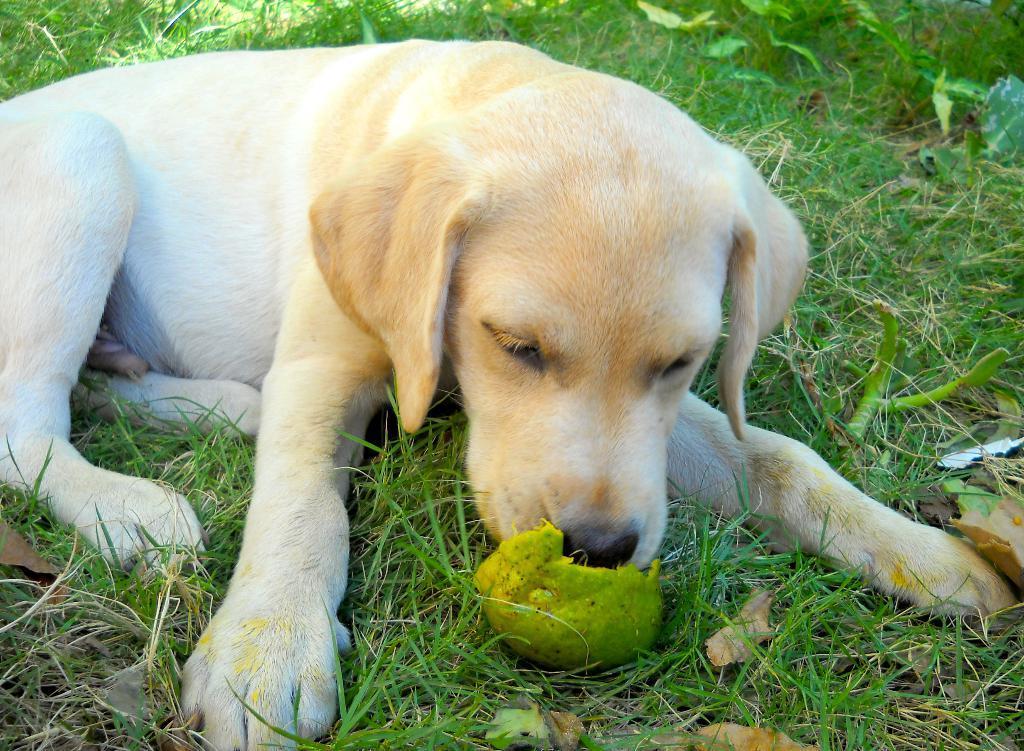Please provide a concise description of this image. In this image we can see a dog on the ground. We can also see some grass, a fruit and some plants. 